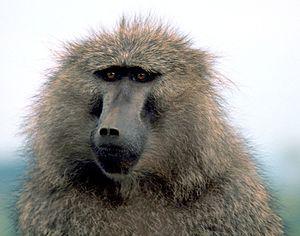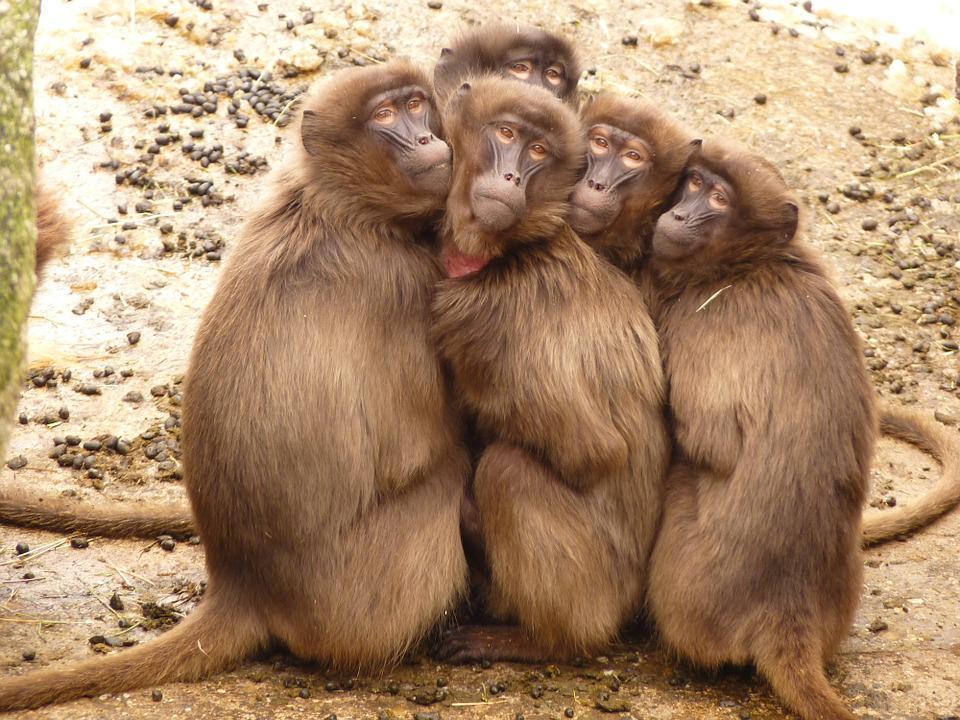The first image is the image on the left, the second image is the image on the right. Given the left and right images, does the statement "There are more monkeys in the image on the right." hold true? Answer yes or no. Yes. The first image is the image on the left, the second image is the image on the right. For the images shown, is this caption "The left image shows exactly one adult baboon and one baby baboon." true? Answer yes or no. No. 